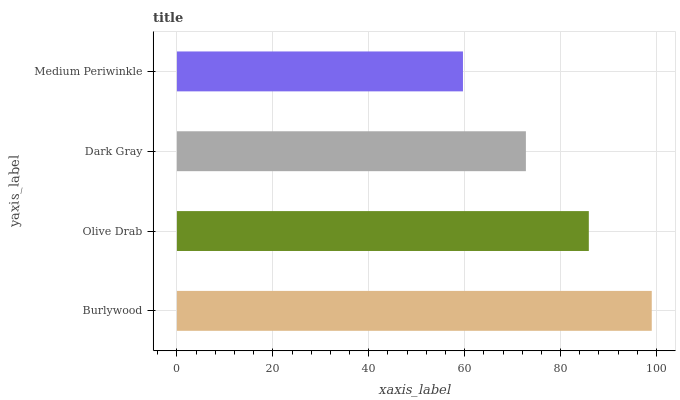Is Medium Periwinkle the minimum?
Answer yes or no. Yes. Is Burlywood the maximum?
Answer yes or no. Yes. Is Olive Drab the minimum?
Answer yes or no. No. Is Olive Drab the maximum?
Answer yes or no. No. Is Burlywood greater than Olive Drab?
Answer yes or no. Yes. Is Olive Drab less than Burlywood?
Answer yes or no. Yes. Is Olive Drab greater than Burlywood?
Answer yes or no. No. Is Burlywood less than Olive Drab?
Answer yes or no. No. Is Olive Drab the high median?
Answer yes or no. Yes. Is Dark Gray the low median?
Answer yes or no. Yes. Is Burlywood the high median?
Answer yes or no. No. Is Olive Drab the low median?
Answer yes or no. No. 